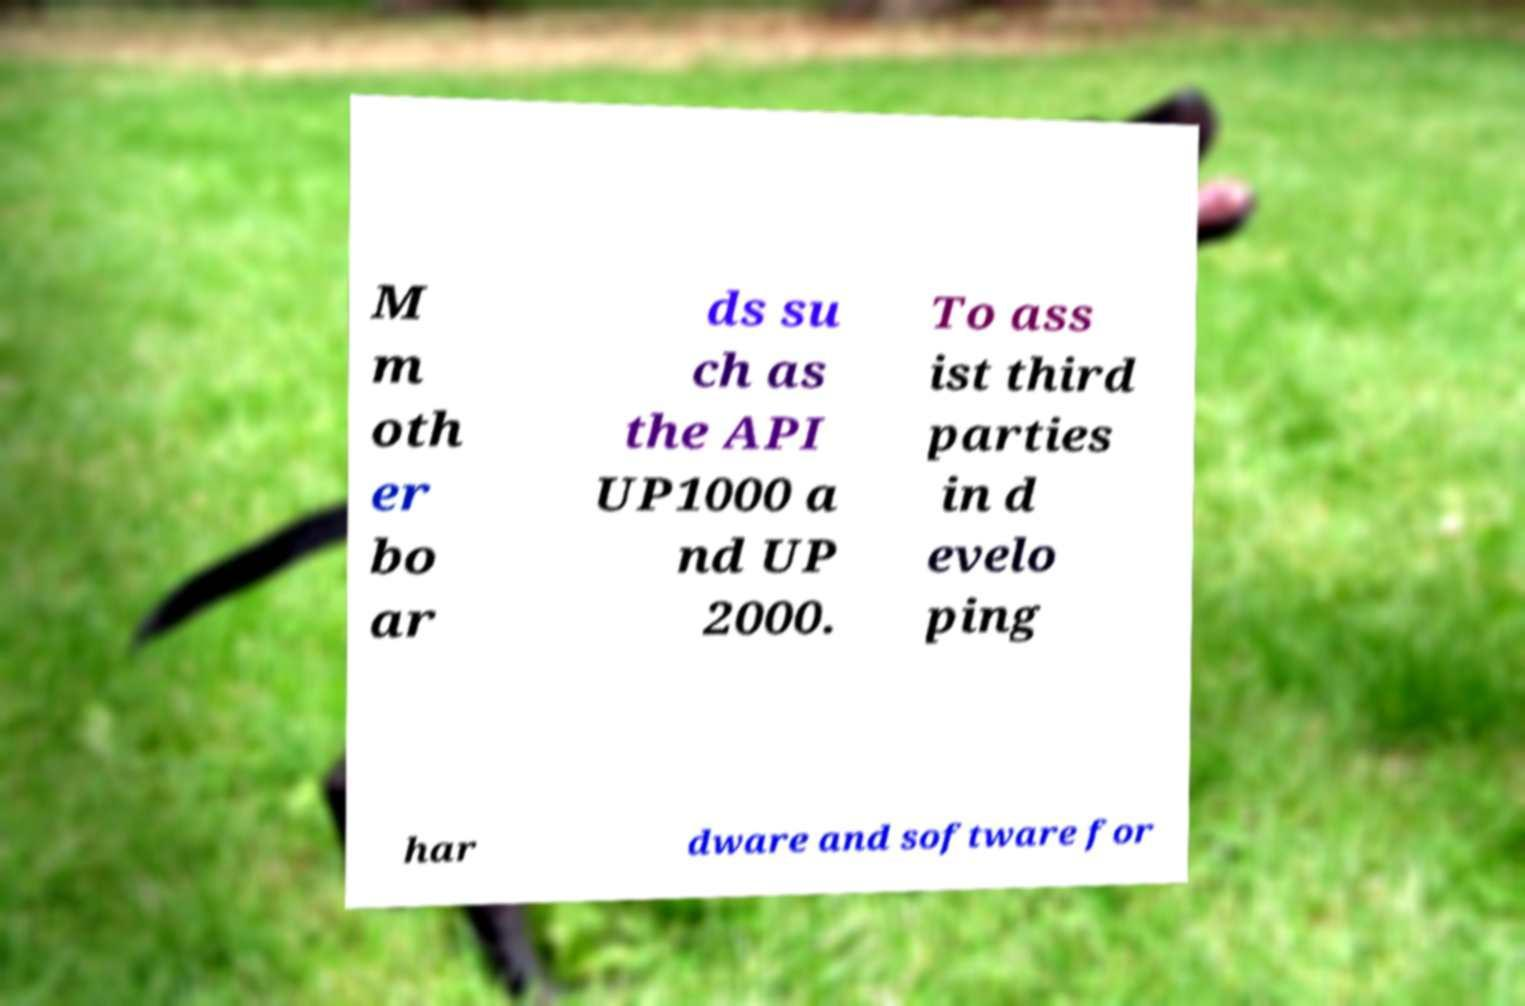Please identify and transcribe the text found in this image. M m oth er bo ar ds su ch as the API UP1000 a nd UP 2000. To ass ist third parties in d evelo ping har dware and software for 